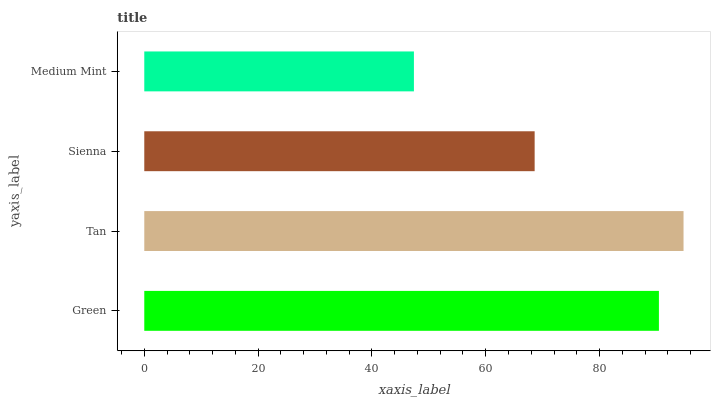Is Medium Mint the minimum?
Answer yes or no. Yes. Is Tan the maximum?
Answer yes or no. Yes. Is Sienna the minimum?
Answer yes or no. No. Is Sienna the maximum?
Answer yes or no. No. Is Tan greater than Sienna?
Answer yes or no. Yes. Is Sienna less than Tan?
Answer yes or no. Yes. Is Sienna greater than Tan?
Answer yes or no. No. Is Tan less than Sienna?
Answer yes or no. No. Is Green the high median?
Answer yes or no. Yes. Is Sienna the low median?
Answer yes or no. Yes. Is Medium Mint the high median?
Answer yes or no. No. Is Green the low median?
Answer yes or no. No. 